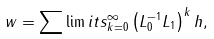<formula> <loc_0><loc_0><loc_500><loc_500>w = \sum \lim i t s _ { k = 0 } ^ { \infty } \left ( L _ { 0 } ^ { - 1 } L _ { 1 } \right ) ^ { k } h ,</formula> 